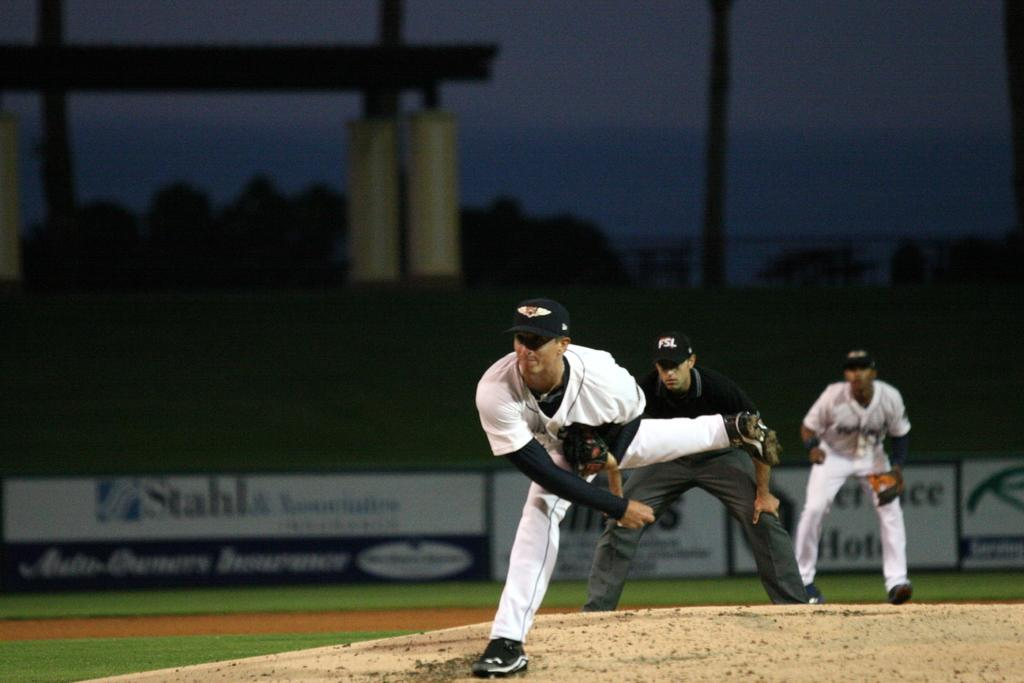Provide a one-sentence caption for the provided image. The pitcher is in action on the mound with an advertisement for Stahl in the background. 